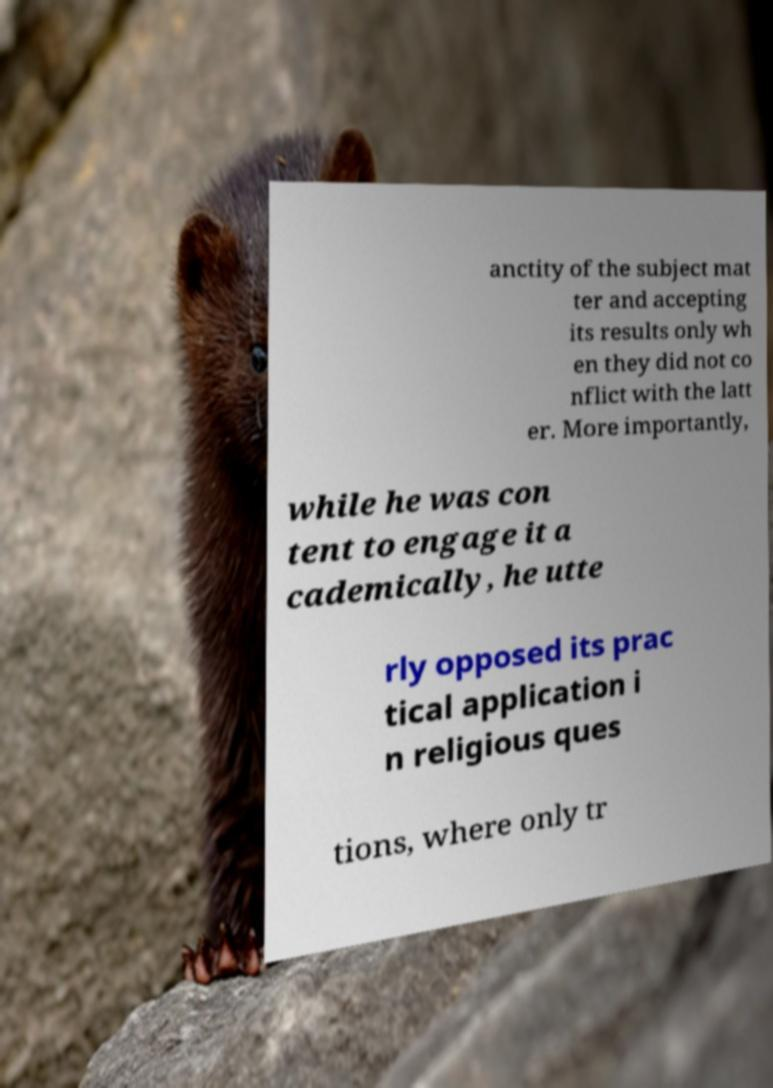Please read and relay the text visible in this image. What does it say? anctity of the subject mat ter and accepting its results only wh en they did not co nflict with the latt er. More importantly, while he was con tent to engage it a cademically, he utte rly opposed its prac tical application i n religious ques tions, where only tr 